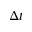Convert formula to latex. <formula><loc_0><loc_0><loc_500><loc_500>{ \Delta t }</formula> 